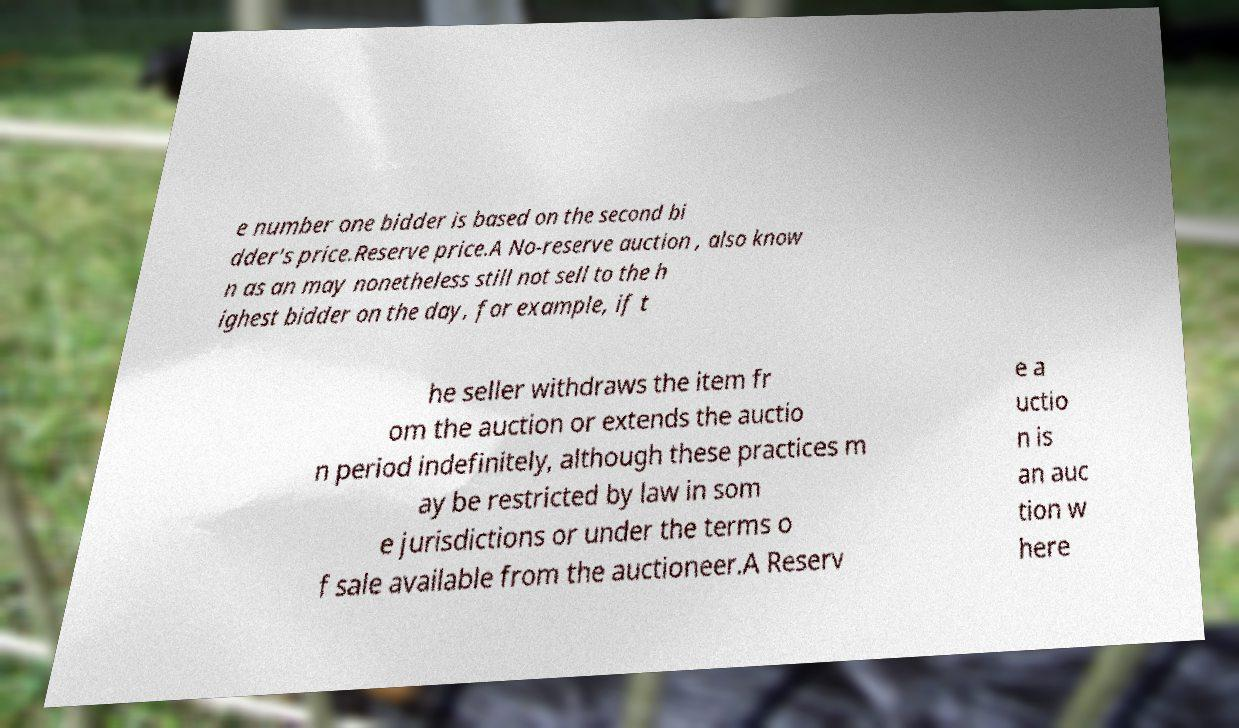Please read and relay the text visible in this image. What does it say? e number one bidder is based on the second bi dder's price.Reserve price.A No-reserve auction , also know n as an may nonetheless still not sell to the h ighest bidder on the day, for example, if t he seller withdraws the item fr om the auction or extends the auctio n period indefinitely, although these practices m ay be restricted by law in som e jurisdictions or under the terms o f sale available from the auctioneer.A Reserv e a uctio n is an auc tion w here 